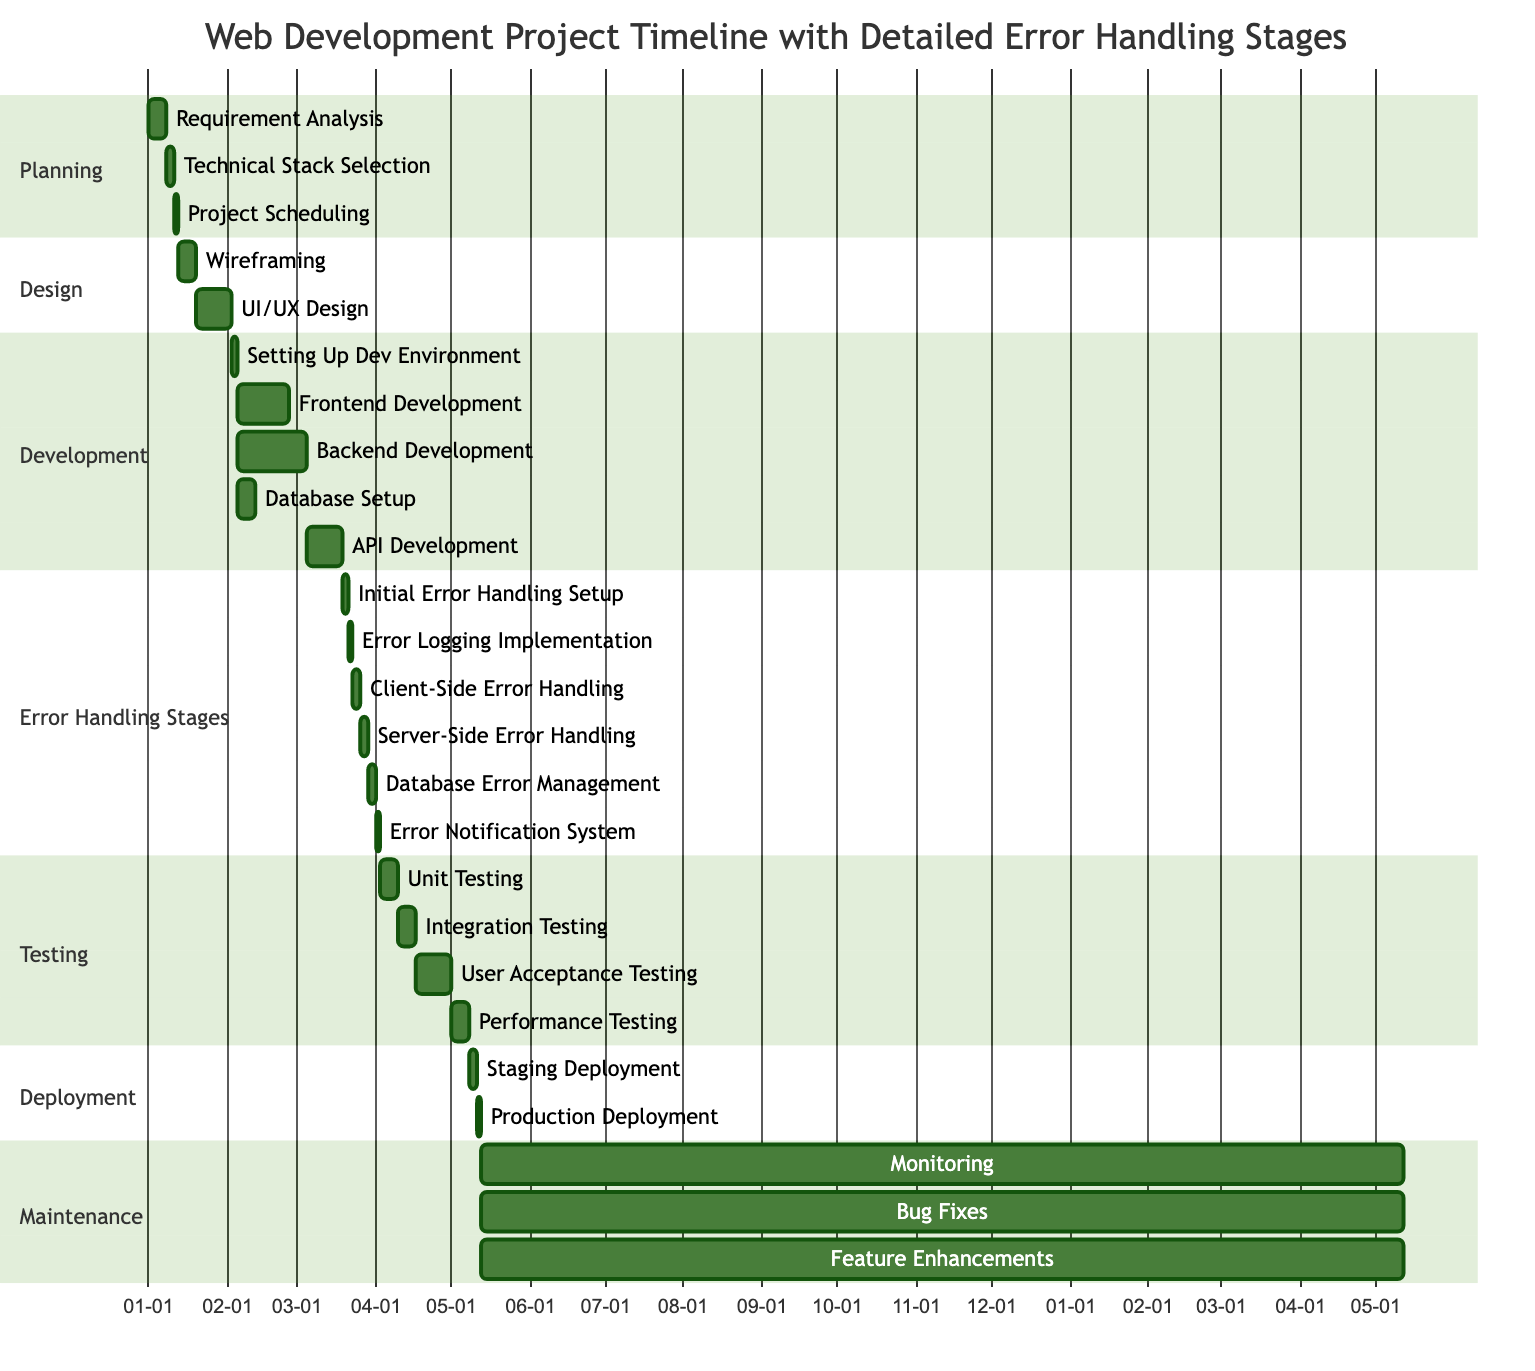What is the duration of the "Requirement Analysis" task? The "Requirement Analysis" task is defined in the "Planning" section and has a duration specified as "1 week."
Answer: 1 week What follows the "API Development" task in the timeline? In the Gantt chart structure, the task that follows "API Development" is "Initial Error Handling Setup," as it is scheduled immediately after "API Development" concludes.
Answer: Initial Error Handling Setup How many tasks are there in the "Development" phase? The "Development" phase includes five tasks: "Setting Up Dev Environment," "Frontend Development," "Backend Development," "Database Setup," and "API Development," making for a total of five tasks.
Answer: 5 What is the total duration for the "Error Handling Stages"? To find the total duration, we add the individual durations of all tasks in this section: "Initial Error Handling Setup" (2 days) + "Error Logging Implementation" (2 days) + "Client-Side Error Handling" (3 days) + "Server-Side Error Handling" (3 days) + "Database Error Management" (3 days) + "Error Notification System" (2 days) = 15 days, translating to 2 weeks and 1 day.
Answer: 15 days What is the first task in the "Testing" phase? The "Testing" phase begins with the task "Unit Testing," which is the first listed task under this section in the diagram.
Answer: Unit Testing How many weeks does the "UI/UX Design" task take? The "UI/UX Design" task has a duration of "2 weeks," which is clearly stated in the "Design" section of the chart.
Answer: 2 weeks Which task has the longest duration in the "Development" phase? Among the tasks in the "Development" phase, "Backend Development" has the longest duration of "4 weeks," making it the task with the biggest time allocation in that phase.
Answer: Backend Development What is the total duration for tasks involving "Error Handling"? The total duration for "Error Handling Stages" tasks is 15 days, made up of multiple shorter tasks combined, which showcases the commitment to proper error handling in the project.
Answer: 15 days How many ongoing tasks are there in the "Maintenance" phase? There are three ongoing tasks listed in the "Maintenance" phase: "Monitoring," "Bug Fixes," and "Feature Enhancements," highlighting the continuous effort required after deployment.
Answer: 3 